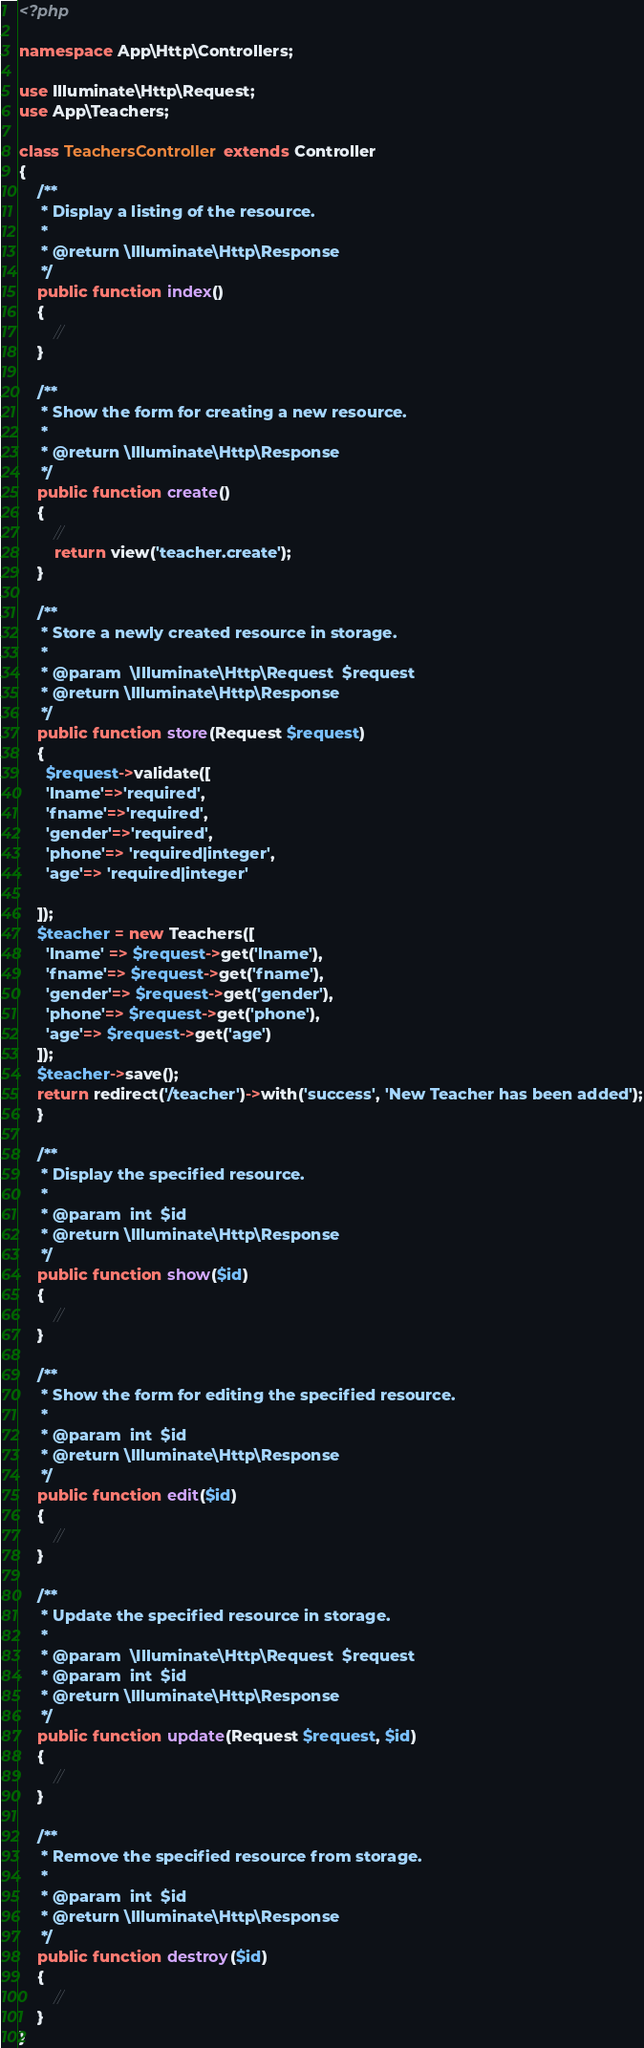<code> <loc_0><loc_0><loc_500><loc_500><_PHP_><?php

namespace App\Http\Controllers;

use Illuminate\Http\Request;
use App\Teachers;

class TeachersController extends Controller
{
    /**
     * Display a listing of the resource.
     *
     * @return \Illuminate\Http\Response
     */
    public function index()
    {
        //
    }

    /**
     * Show the form for creating a new resource.
     *
     * @return \Illuminate\Http\Response
     */
    public function create()
    {
        //
        return view('teacher.create');
    }

    /**
     * Store a newly created resource in storage.
     *
     * @param  \Illuminate\Http\Request  $request
     * @return \Illuminate\Http\Response
     */
    public function store(Request $request)
    {
      $request->validate([
      'lname'=>'required',
      'fname'=>'required',
      'gender'=>'required',
      'phone'=> 'required|integer',
      'age'=> 'required|integer'

    ]);
    $teacher = new Teachers([
      'lname' => $request->get('lname'),
      'fname'=> $request->get('fname'),
      'gender'=> $request->get('gender'),
      'phone'=> $request->get('phone'),
      'age'=> $request->get('age')
    ]);
    $teacher->save();
    return redirect('/teacher')->with('success', 'New Teacher has been added');
    }

    /**
     * Display the specified resource.
     *
     * @param  int  $id
     * @return \Illuminate\Http\Response
     */
    public function show($id)
    {
        //
    }

    /**
     * Show the form for editing the specified resource.
     *
     * @param  int  $id
     * @return \Illuminate\Http\Response
     */
    public function edit($id)
    {
        //
    }

    /**
     * Update the specified resource in storage.
     *
     * @param  \Illuminate\Http\Request  $request
     * @param  int  $id
     * @return \Illuminate\Http\Response
     */
    public function update(Request $request, $id)
    {
        //
    }

    /**
     * Remove the specified resource from storage.
     *
     * @param  int  $id
     * @return \Illuminate\Http\Response
     */
    public function destroy($id)
    {
        //
    }
}
</code> 